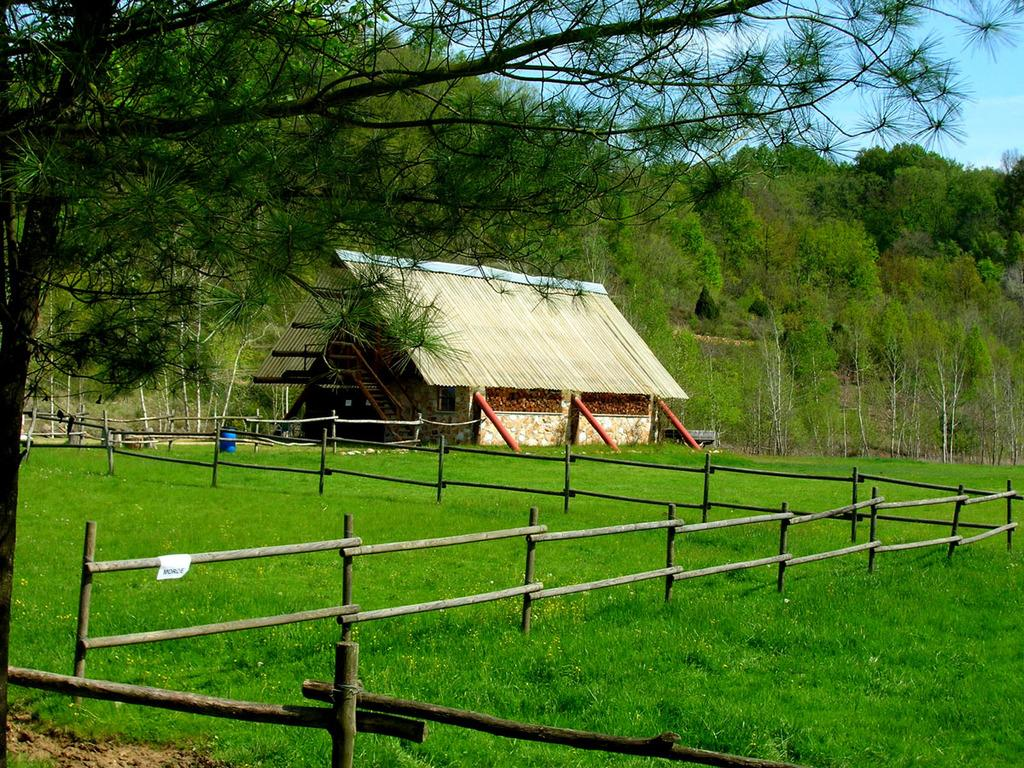What type of structure is in the image? There is a hut in the image. What is at the bottom of the image? There is green grass at the bottom of the image. What type of fencing is in the image? There is a wooden fencing in the image. What can be seen in the background of the image? There are trees in the background of the image. How does the notebook help to increase the chain's length in the image? There is no notebook or chain present in the image, so this question cannot be answered. 